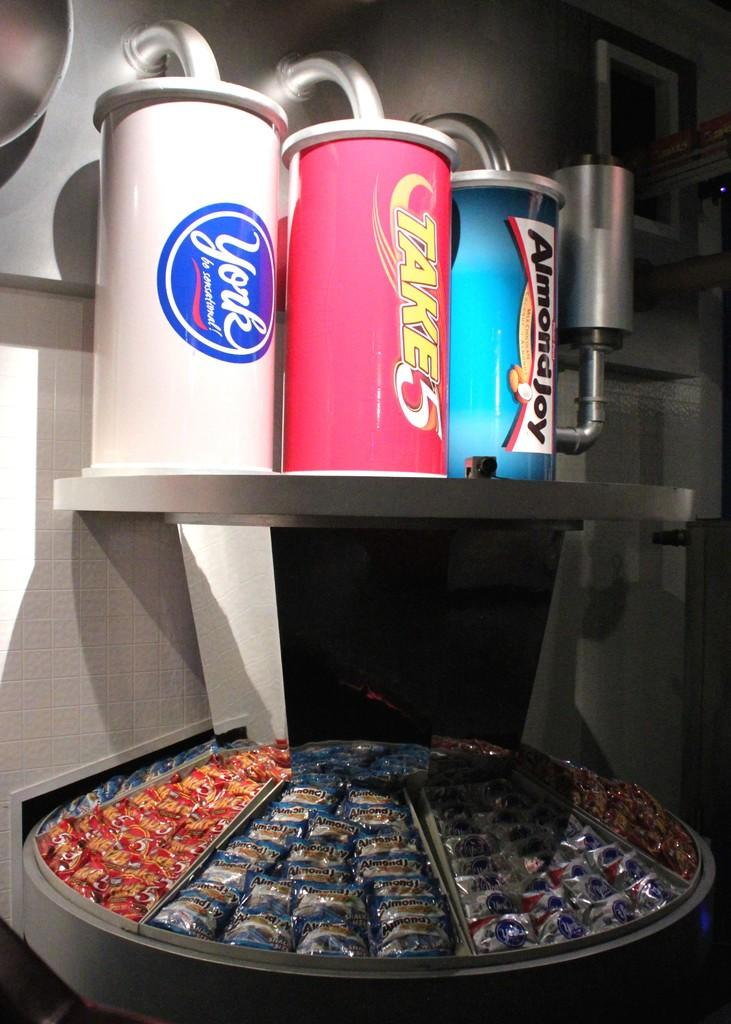<image>
Offer a succinct explanation of the picture presented. A lot of candy bars including Almondjoy and Take5 